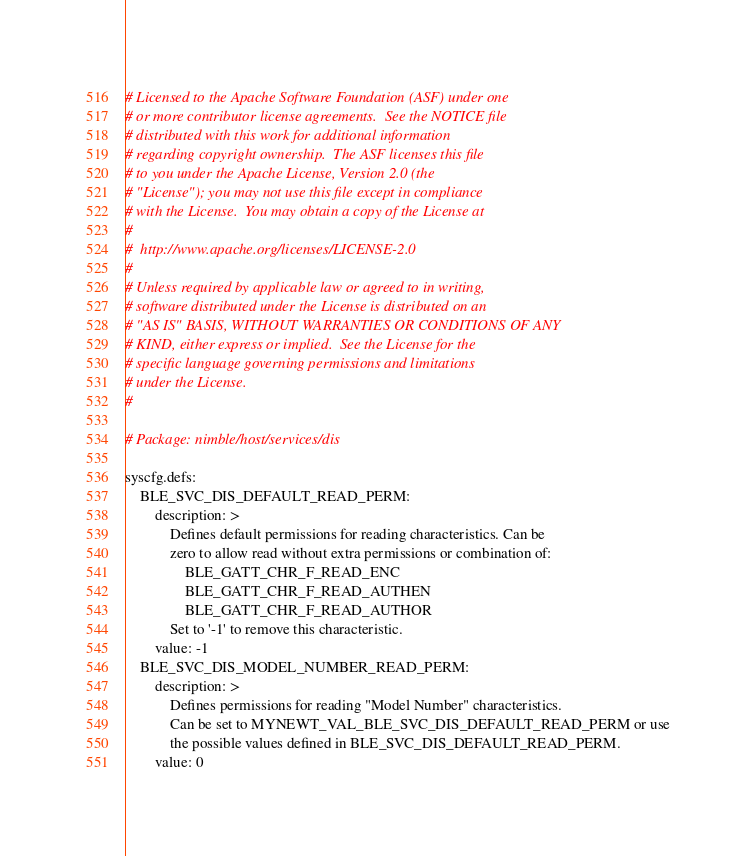<code> <loc_0><loc_0><loc_500><loc_500><_YAML_># Licensed to the Apache Software Foundation (ASF) under one
# or more contributor license agreements.  See the NOTICE file
# distributed with this work for additional information
# regarding copyright ownership.  The ASF licenses this file
# to you under the Apache License, Version 2.0 (the
# "License"); you may not use this file except in compliance
# with the License.  You may obtain a copy of the License at
#
#  http://www.apache.org/licenses/LICENSE-2.0
#
# Unless required by applicable law or agreed to in writing,
# software distributed under the License is distributed on an
# "AS IS" BASIS, WITHOUT WARRANTIES OR CONDITIONS OF ANY
# KIND, either express or implied.  See the License for the
# specific language governing permissions and limitations
# under the License.
#

# Package: nimble/host/services/dis

syscfg.defs:
    BLE_SVC_DIS_DEFAULT_READ_PERM:
        description: >
            Defines default permissions for reading characteristics. Can be
            zero to allow read without extra permissions or combination of:
                BLE_GATT_CHR_F_READ_ENC
                BLE_GATT_CHR_F_READ_AUTHEN
                BLE_GATT_CHR_F_READ_AUTHOR
            Set to '-1' to remove this characteristic.
        value: -1
    BLE_SVC_DIS_MODEL_NUMBER_READ_PERM:
        description: >
            Defines permissions for reading "Model Number" characteristics.
            Can be set to MYNEWT_VAL_BLE_SVC_DIS_DEFAULT_READ_PERM or use
            the possible values defined in BLE_SVC_DIS_DEFAULT_READ_PERM.
        value: 0</code> 